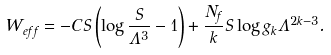Convert formula to latex. <formula><loc_0><loc_0><loc_500><loc_500>W _ { e f f } = - C S \left ( \log { \frac { S } { \Lambda ^ { 3 } } } - 1 \right ) + \frac { N _ { f } } { k } S \log { g _ { k } \Lambda ^ { 2 k - 3 } } .</formula> 